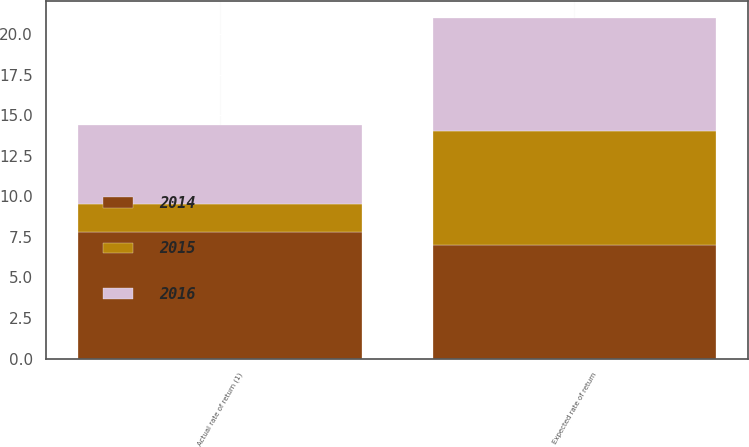Convert chart to OTSL. <chart><loc_0><loc_0><loc_500><loc_500><stacked_bar_chart><ecel><fcel>Expected rate of return<fcel>Actual rate of return (1)<nl><fcel>2016<fcel>7<fcel>4.9<nl><fcel>2015<fcel>7<fcel>1.7<nl><fcel>2014<fcel>7<fcel>7.8<nl></chart> 